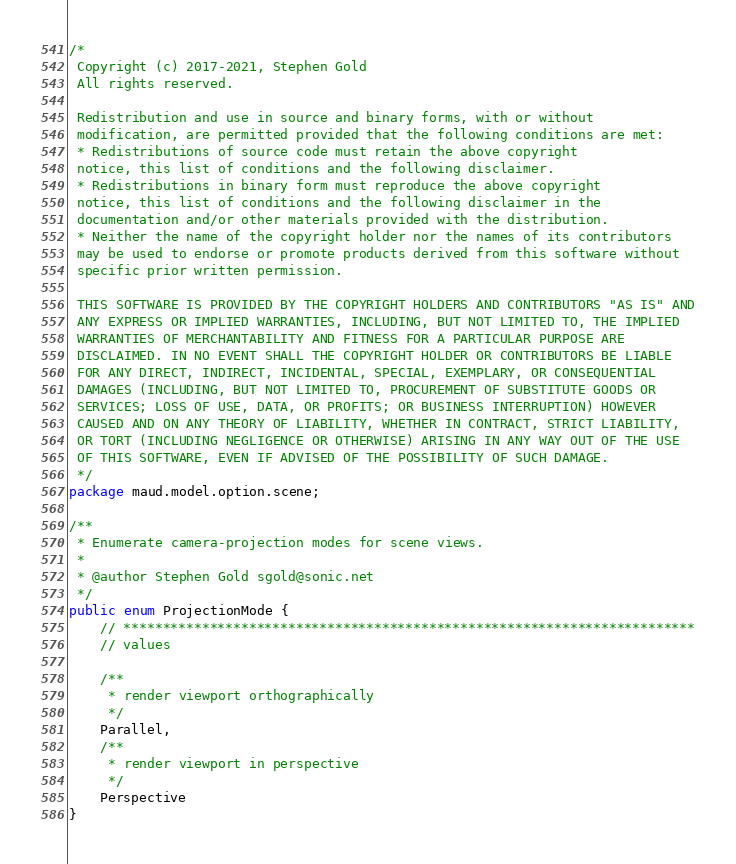<code> <loc_0><loc_0><loc_500><loc_500><_Java_>/*
 Copyright (c) 2017-2021, Stephen Gold
 All rights reserved.

 Redistribution and use in source and binary forms, with or without
 modification, are permitted provided that the following conditions are met:
 * Redistributions of source code must retain the above copyright
 notice, this list of conditions and the following disclaimer.
 * Redistributions in binary form must reproduce the above copyright
 notice, this list of conditions and the following disclaimer in the
 documentation and/or other materials provided with the distribution.
 * Neither the name of the copyright holder nor the names of its contributors
 may be used to endorse or promote products derived from this software without
 specific prior written permission.

 THIS SOFTWARE IS PROVIDED BY THE COPYRIGHT HOLDERS AND CONTRIBUTORS "AS IS" AND
 ANY EXPRESS OR IMPLIED WARRANTIES, INCLUDING, BUT NOT LIMITED TO, THE IMPLIED
 WARRANTIES OF MERCHANTABILITY AND FITNESS FOR A PARTICULAR PURPOSE ARE
 DISCLAIMED. IN NO EVENT SHALL THE COPYRIGHT HOLDER OR CONTRIBUTORS BE LIABLE
 FOR ANY DIRECT, INDIRECT, INCIDENTAL, SPECIAL, EXEMPLARY, OR CONSEQUENTIAL
 DAMAGES (INCLUDING, BUT NOT LIMITED TO, PROCUREMENT OF SUBSTITUTE GOODS OR
 SERVICES; LOSS OF USE, DATA, OR PROFITS; OR BUSINESS INTERRUPTION) HOWEVER
 CAUSED AND ON ANY THEORY OF LIABILITY, WHETHER IN CONTRACT, STRICT LIABILITY,
 OR TORT (INCLUDING NEGLIGENCE OR OTHERWISE) ARISING IN ANY WAY OUT OF THE USE
 OF THIS SOFTWARE, EVEN IF ADVISED OF THE POSSIBILITY OF SUCH DAMAGE.
 */
package maud.model.option.scene;

/**
 * Enumerate camera-projection modes for scene views.
 *
 * @author Stephen Gold sgold@sonic.net
 */
public enum ProjectionMode {
    // *************************************************************************
    // values

    /**
     * render viewport orthographically
     */
    Parallel,
    /**
     * render viewport in perspective
     */
    Perspective
}
</code> 